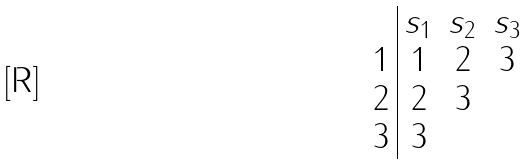Convert formula to latex. <formula><loc_0><loc_0><loc_500><loc_500>\begin{array} { c | c c c } & s _ { 1 } & s _ { 2 } & s _ { 3 } \\ 1 & 1 & 2 & 3 \\ 2 & 2 & 3 & \\ 3 & 3 & & \end{array}</formula> 